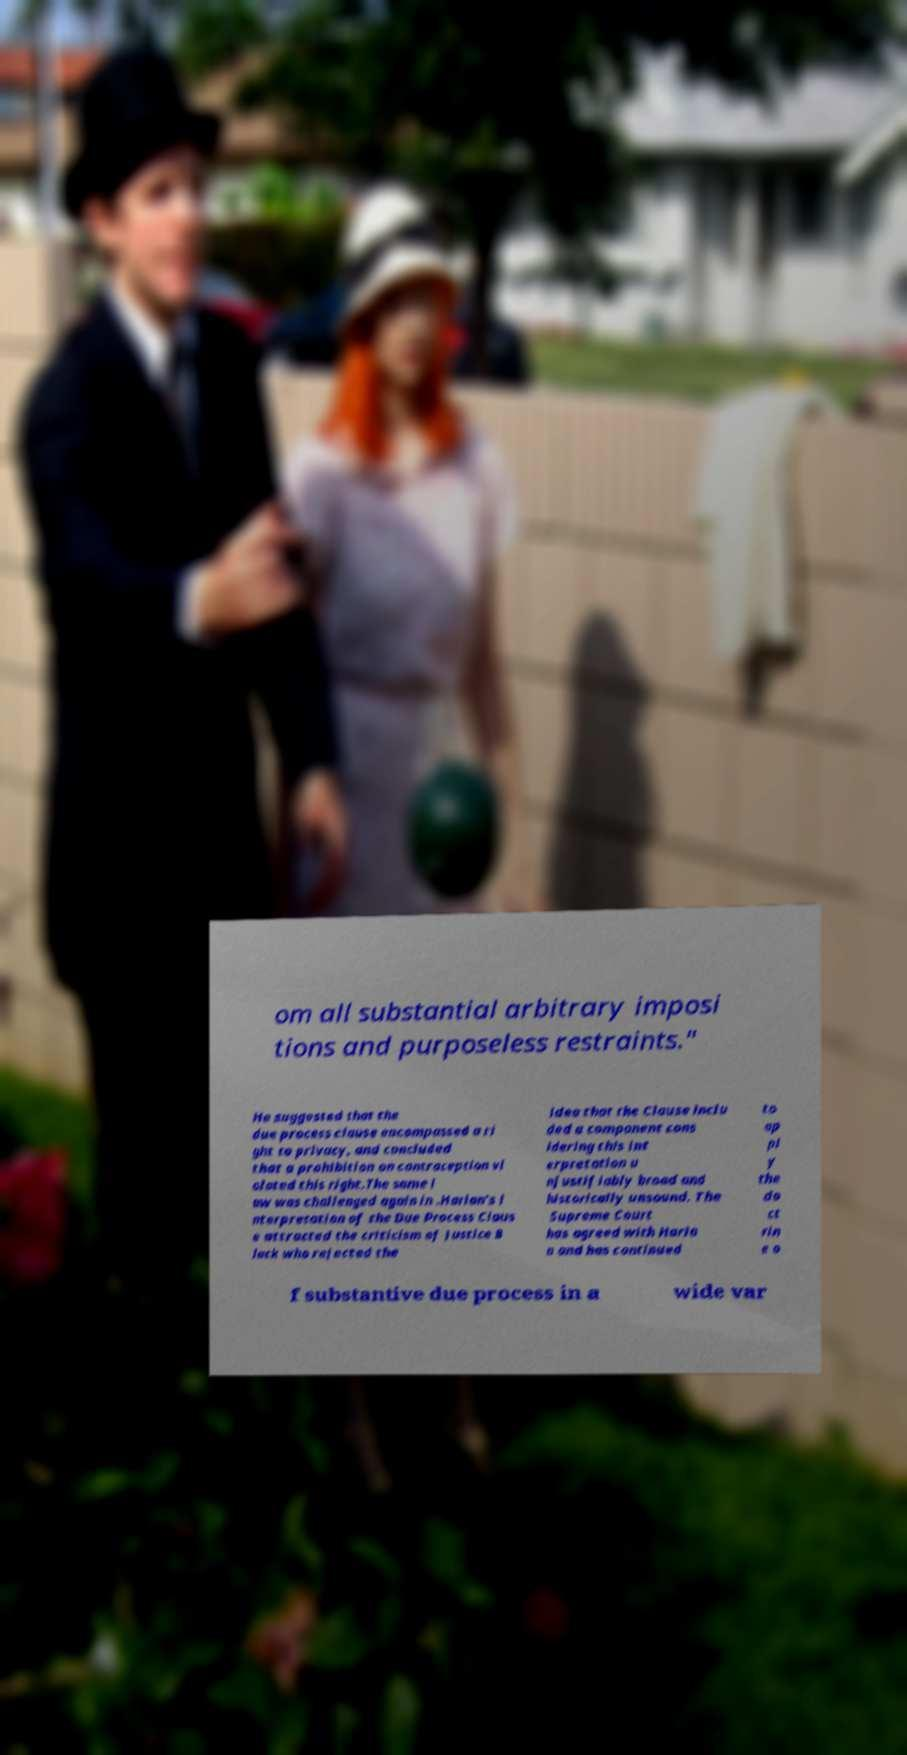Can you accurately transcribe the text from the provided image for me? om all substantial arbitrary imposi tions and purposeless restraints." He suggested that the due process clause encompassed a ri ght to privacy, and concluded that a prohibition on contraception vi olated this right.The same l aw was challenged again in .Harlan's i nterpretation of the Due Process Claus e attracted the criticism of Justice B lack who rejected the idea that the Clause inclu ded a component cons idering this int erpretation u njustifiably broad and historically unsound. The Supreme Court has agreed with Harla n and has continued to ap pl y the do ct rin e o f substantive due process in a wide var 